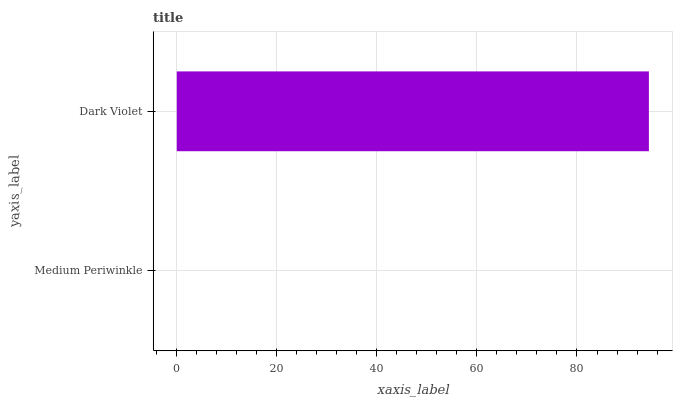Is Medium Periwinkle the minimum?
Answer yes or no. Yes. Is Dark Violet the maximum?
Answer yes or no. Yes. Is Dark Violet the minimum?
Answer yes or no. No. Is Dark Violet greater than Medium Periwinkle?
Answer yes or no. Yes. Is Medium Periwinkle less than Dark Violet?
Answer yes or no. Yes. Is Medium Periwinkle greater than Dark Violet?
Answer yes or no. No. Is Dark Violet less than Medium Periwinkle?
Answer yes or no. No. Is Dark Violet the high median?
Answer yes or no. Yes. Is Medium Periwinkle the low median?
Answer yes or no. Yes. Is Medium Periwinkle the high median?
Answer yes or no. No. Is Dark Violet the low median?
Answer yes or no. No. 